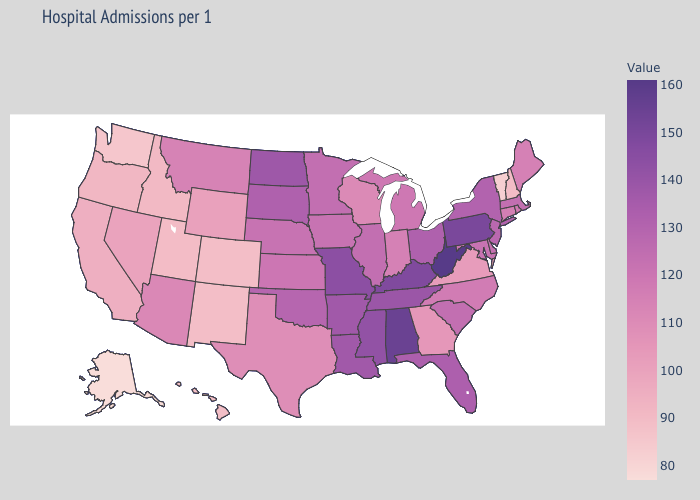Does Oklahoma have the highest value in the USA?
Write a very short answer. No. Does Vermont have the lowest value in the Northeast?
Write a very short answer. Yes. Does the map have missing data?
Quick response, please. No. Does Wyoming have a lower value than Ohio?
Keep it brief. Yes. Does the map have missing data?
Answer briefly. No. Does West Virginia have the highest value in the USA?
Answer briefly. Yes. Among the states that border Indiana , does Ohio have the lowest value?
Keep it brief. No. 